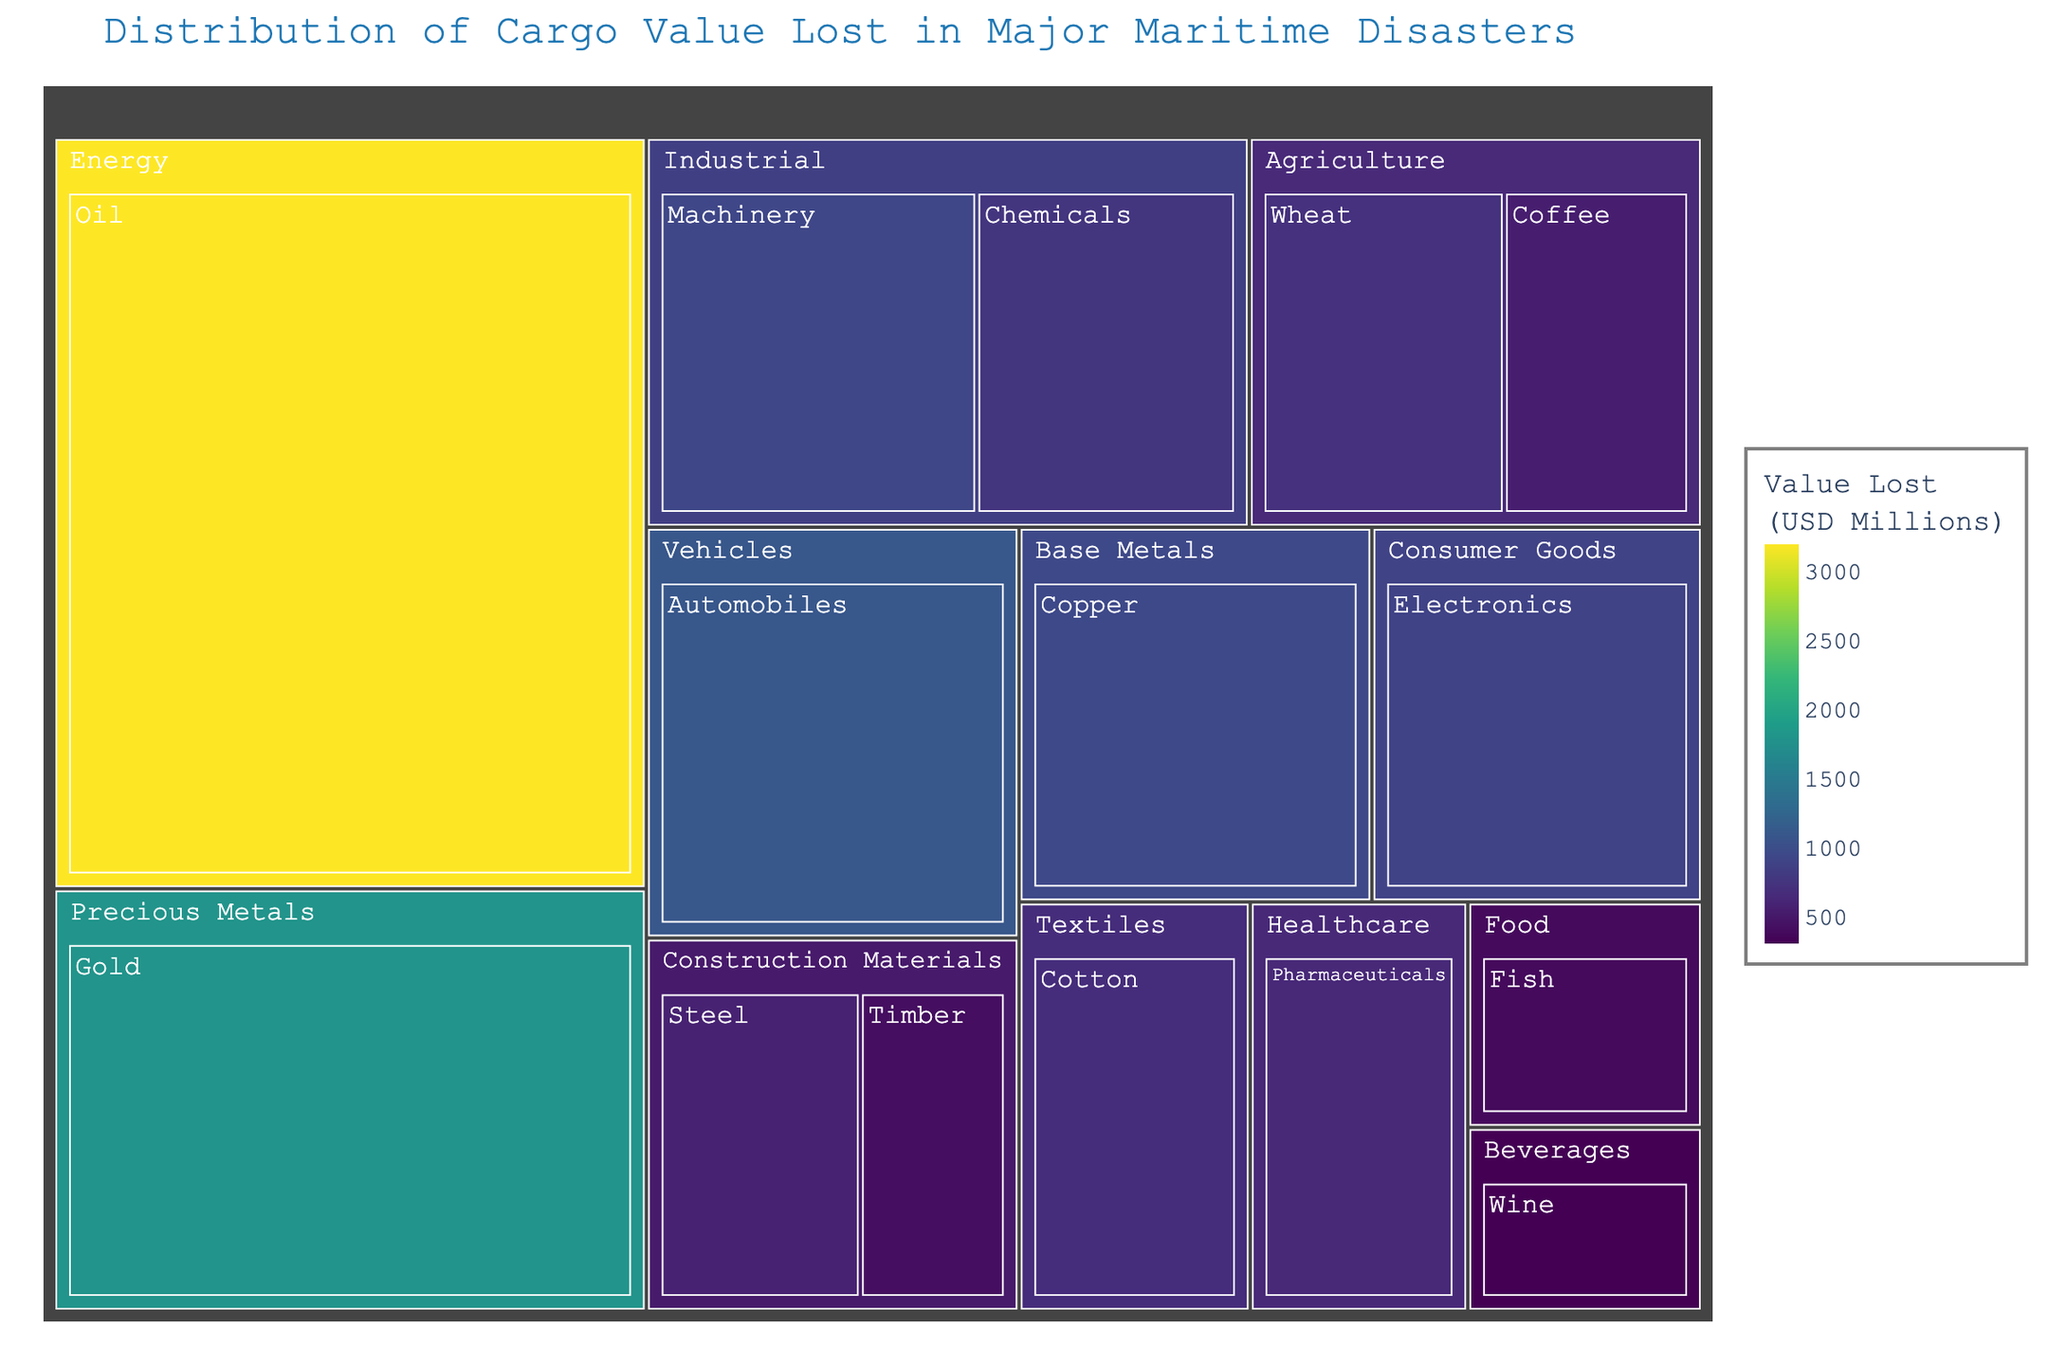What's the title of the treemap? The title of the treemap is located at the top of the figure. In this case, it is displayed in a large font size and is colored in a shade of blue.
Answer: Distribution of Cargo Value Lost in Major Maritime Disasters Which commodity has the highest cargo value lost, and how much is it? To identify the commodity with the highest value lost, look for the largest block in the treemap. The size and color intensity will indicate the highest value. In this case, the largest block is for Oil.
Answer: Oil, $3200 Million What is the total value lost in the Agriculture category? First, identify all commodities under the Agriculture category, which are Wheat and Coffee. Sum their values: 720 (Wheat) + 550 (Coffee) = 1270.
Answer: $1270 Million Which category has the second highest total value lost, and how much is it? To find this, look at the size of the blocks by category. The largest category is Energy, followed by Precious Metals. Check the sum for Precious Metals, which includes Gold: $1800 Million.
Answer: Precious Metals, $1800 Million Between Automobiles and Electronics, which commodity has a greater value lost? Identify the blocks for Automobiles and Electronics, and compare their values. Automobiles have $1100 Million and Electronics have $890 Million.
Answer: Automobiles How much more value was lost in Copper compared to Steel? Identify the blocks for Copper (Base Metals) and Steel (Construction Materials) and subtract their values. Copper is $950 Million and Steel is $580 Million. The difference is 950 - 580 = 370.
Answer: $370 Million What is the average value lost in the Industrial category? Identify all commodities under Industrial: Chemicals and Machinery. Sum their values: 760 + 930 = 1690. There are 2 commodities, so the average is 1690 / 2 = 845.
Answer: $845 Million Which category experienced the least total value lost and what is the value? This requires summing values for each category and identifying the smallest sum. Beverages only has Wine listed: $310 Million.
Answer: Beverages, $310 Million How does the value lost in Pharmaceuticals compare to that in Timber? Compare the values directly by identifying their blocks. Pharmaceuticals (Healthcare) has $640 Million and Timber (Construction Materials) has $420 Million.
Answer: Pharmaceuticals is higher Which two categories combined have a total value lost exceeding that of Precious Metals? Compare summed values of pairs of categories to ensure they exceed $1800 Million (Precious Metals). Energy ($3200 Million) alone suffices, but Agriculture ($1270 Million) combined with Energy ($3200 Million) is $4470 Million, which exceeds $1800 Million.
Answer: Energy and Agriculture 